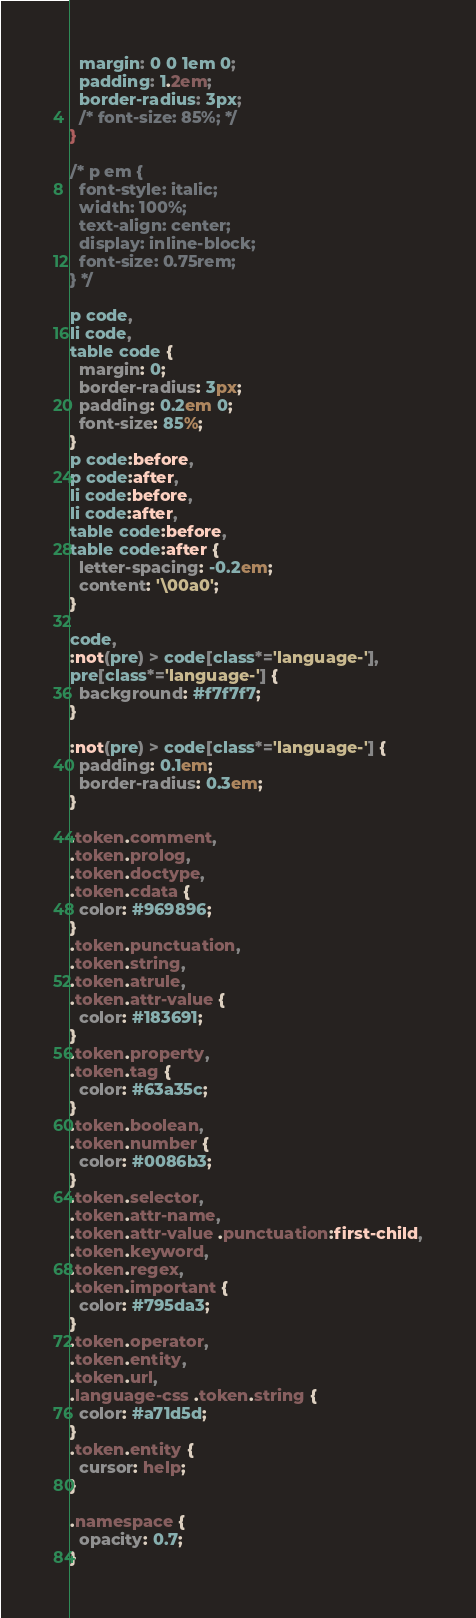<code> <loc_0><loc_0><loc_500><loc_500><_CSS_>  margin: 0 0 1em 0;
  padding: 1.2em;
  border-radius: 3px;
  /* font-size: 85%; */
}

/* p em {
  font-style: italic;
  width: 100%;
  text-align: center;
  display: inline-block;
  font-size: 0.75rem;
} */

p code,
li code,
table code {
  margin: 0;
  border-radius: 3px;
  padding: 0.2em 0;
  font-size: 85%;
}
p code:before,
p code:after,
li code:before,
li code:after,
table code:before,
table code:after {
  letter-spacing: -0.2em;
  content: '\00a0';
}

code,
:not(pre) > code[class*='language-'],
pre[class*='language-'] {
  background: #f7f7f7;
}

:not(pre) > code[class*='language-'] {
  padding: 0.1em;
  border-radius: 0.3em;
}

.token.comment,
.token.prolog,
.token.doctype,
.token.cdata {
  color: #969896;
}
.token.punctuation,
.token.string,
.token.atrule,
.token.attr-value {
  color: #183691;
}
.token.property,
.token.tag {
  color: #63a35c;
}
.token.boolean,
.token.number {
  color: #0086b3;
}
.token.selector,
.token.attr-name,
.token.attr-value .punctuation:first-child,
.token.keyword,
.token.regex,
.token.important {
  color: #795da3;
}
.token.operator,
.token.entity,
.token.url,
.language-css .token.string {
  color: #a71d5d;
}
.token.entity {
  cursor: help;
}

.namespace {
  opacity: 0.7;
}
</code> 